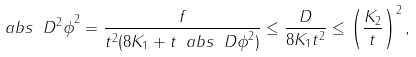Convert formula to latex. <formula><loc_0><loc_0><loc_500><loc_500>\ a b s { \ D ^ { 2 } \phi } ^ { 2 } = \frac { f } { t ^ { 2 } ( 8 K _ { 1 } + t \ a b s { \ D \phi } ^ { 2 } ) } \leq \frac { D } { 8 K _ { 1 } t ^ { 2 } } \leq \left ( \frac { K _ { 2 } } { t } \right ) ^ { 2 } ,</formula> 